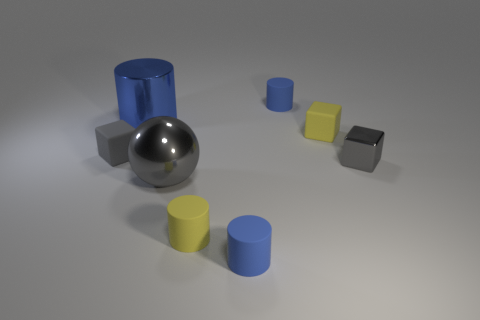Is there anything else that has the same shape as the big gray metal thing?
Your answer should be compact. No. What number of other objects are the same material as the small yellow cube?
Your answer should be compact. 4. Is the large blue cylinder made of the same material as the gray thing that is to the right of the metal sphere?
Provide a succinct answer. Yes. Is the number of tiny yellow cubes behind the small yellow matte block less than the number of small yellow matte things left of the blue metallic cylinder?
Provide a succinct answer. No. What color is the tiny matte block on the right side of the big blue metallic thing?
Give a very brief answer. Yellow. How many other objects are there of the same color as the big cylinder?
Provide a succinct answer. 2. Is the size of the yellow cylinder that is in front of the gray metallic cube the same as the small metal block?
Your answer should be compact. Yes. What number of big gray objects are on the left side of the small gray metallic object?
Your response must be concise. 1. Is there a object that has the same size as the yellow cylinder?
Your answer should be very brief. Yes. Is the color of the small shiny cube the same as the shiny sphere?
Your response must be concise. Yes. 